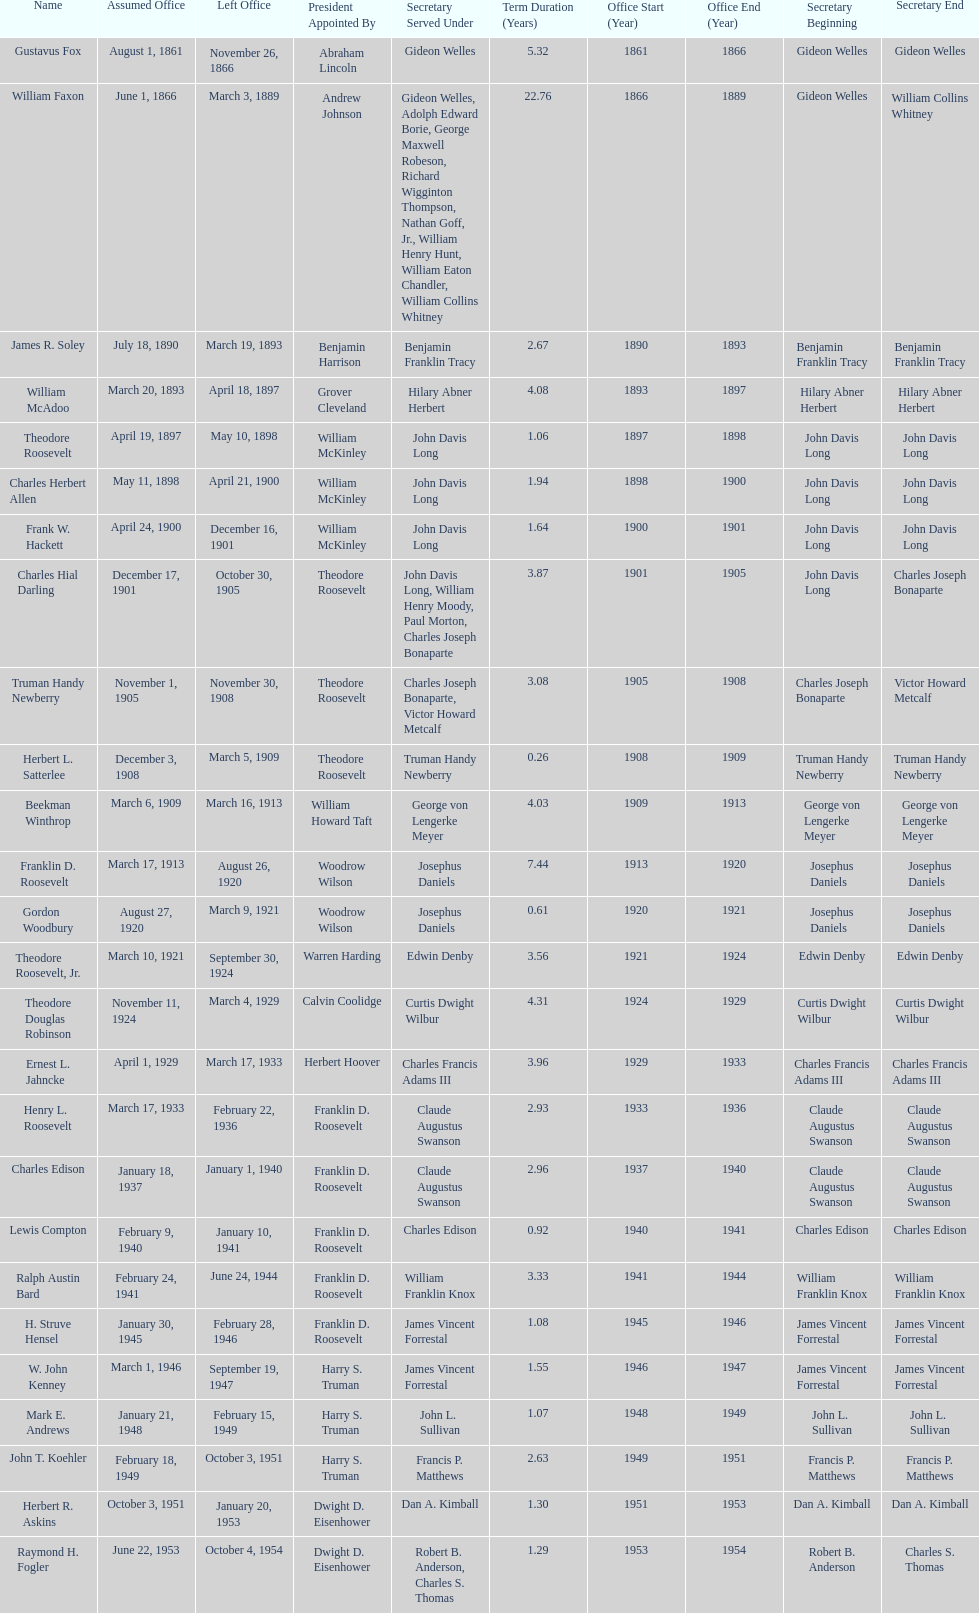Who was the first assistant secretary of the navy? Gustavus Fox. 